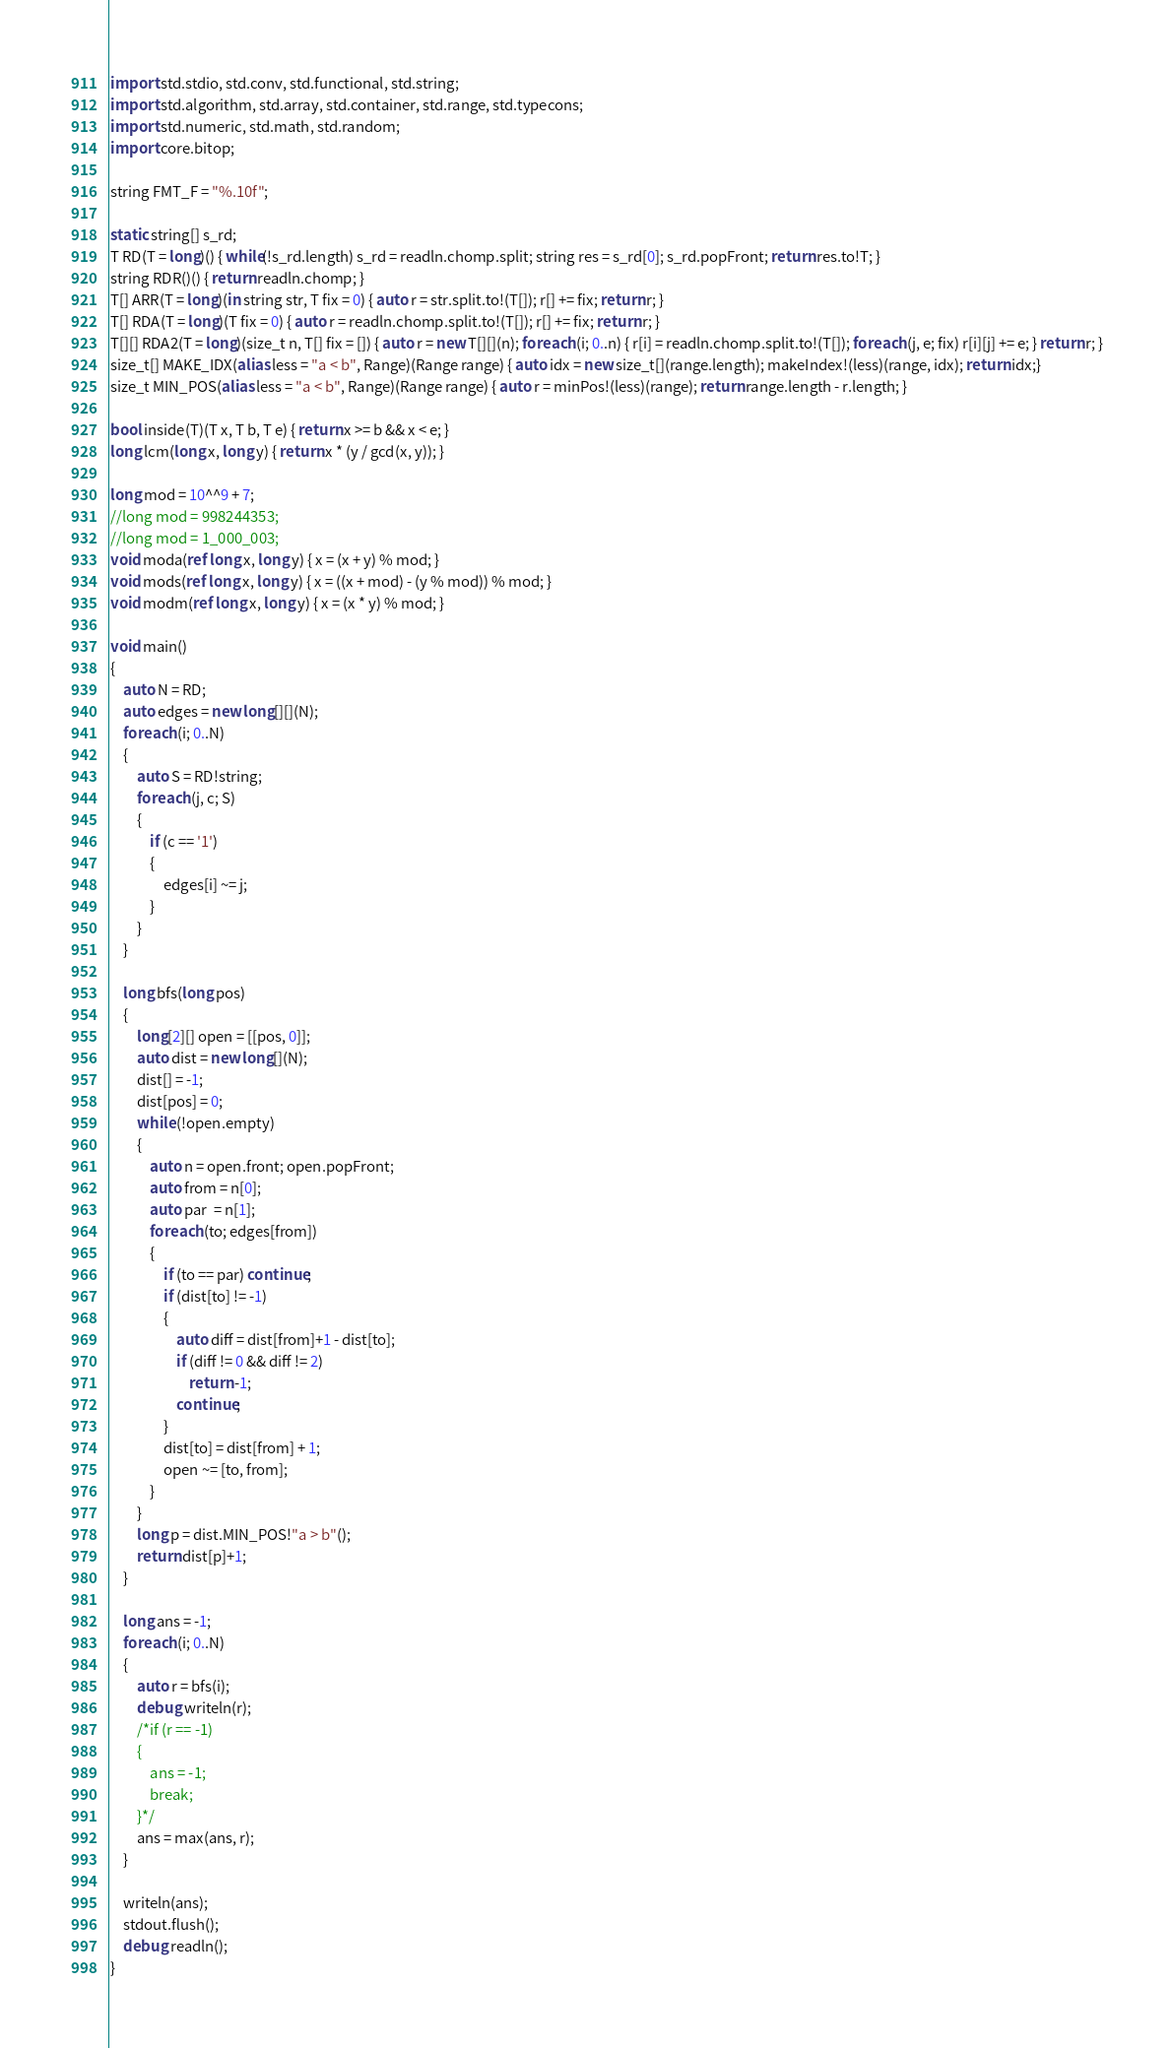Convert code to text. <code><loc_0><loc_0><loc_500><loc_500><_D_>import std.stdio, std.conv, std.functional, std.string;
import std.algorithm, std.array, std.container, std.range, std.typecons;
import std.numeric, std.math, std.random;
import core.bitop;

string FMT_F = "%.10f";

static string[] s_rd;
T RD(T = long)() { while(!s_rd.length) s_rd = readln.chomp.split; string res = s_rd[0]; s_rd.popFront; return res.to!T; }
string RDR()() { return readln.chomp; }
T[] ARR(T = long)(in string str, T fix = 0) { auto r = str.split.to!(T[]); r[] += fix; return r; }
T[] RDA(T = long)(T fix = 0) { auto r = readln.chomp.split.to!(T[]); r[] += fix; return r; }
T[][] RDA2(T = long)(size_t n, T[] fix = []) { auto r = new T[][](n); foreach (i; 0..n) { r[i] = readln.chomp.split.to!(T[]); foreach (j, e; fix) r[i][j] += e; } return r; }
size_t[] MAKE_IDX(alias less = "a < b", Range)(Range range) { auto idx = new size_t[](range.length); makeIndex!(less)(range, idx); return idx;}
size_t MIN_POS(alias less = "a < b", Range)(Range range) { auto r = minPos!(less)(range); return range.length - r.length; }

bool inside(T)(T x, T b, T e) { return x >= b && x < e; }
long lcm(long x, long y) { return x * (y / gcd(x, y)); }

long mod = 10^^9 + 7;
//long mod = 998244353;
//long mod = 1_000_003;
void moda(ref long x, long y) { x = (x + y) % mod; }
void mods(ref long x, long y) { x = ((x + mod) - (y % mod)) % mod; }
void modm(ref long x, long y) { x = (x * y) % mod; }

void main()
{
	auto N = RD;
	auto edges = new long[][](N);
	foreach (i; 0..N)
	{
		auto S = RD!string;
		foreach (j, c; S)
		{
			if (c == '1')
			{
				edges[i] ~= j;
			}
		}
	}

	long bfs(long pos)
	{
		long[2][] open = [[pos, 0]];
		auto dist = new long[](N);
		dist[] = -1;
		dist[pos] = 0;
		while (!open.empty)
		{
			auto n = open.front; open.popFront;
			auto from = n[0];
			auto par  = n[1];
			foreach (to; edges[from])
			{
				if (to == par) continue;
				if (dist[to] != -1)
				{
					auto diff = dist[from]+1 - dist[to];
					if (diff != 0 && diff != 2)
						return -1;
					continue;
				}
				dist[to] = dist[from] + 1;
				open ~= [to, from];
			}
		}
		long p = dist.MIN_POS!"a > b"();
		return dist[p]+1;
	}

	long ans = -1;
	foreach (i; 0..N)
	{
		auto r = bfs(i);
		debug writeln(r);
		/*if (r == -1)
		{
			ans = -1;
			break;
		}*/
		ans = max(ans, r);
	}

	writeln(ans);
	stdout.flush();
	debug readln();
}</code> 